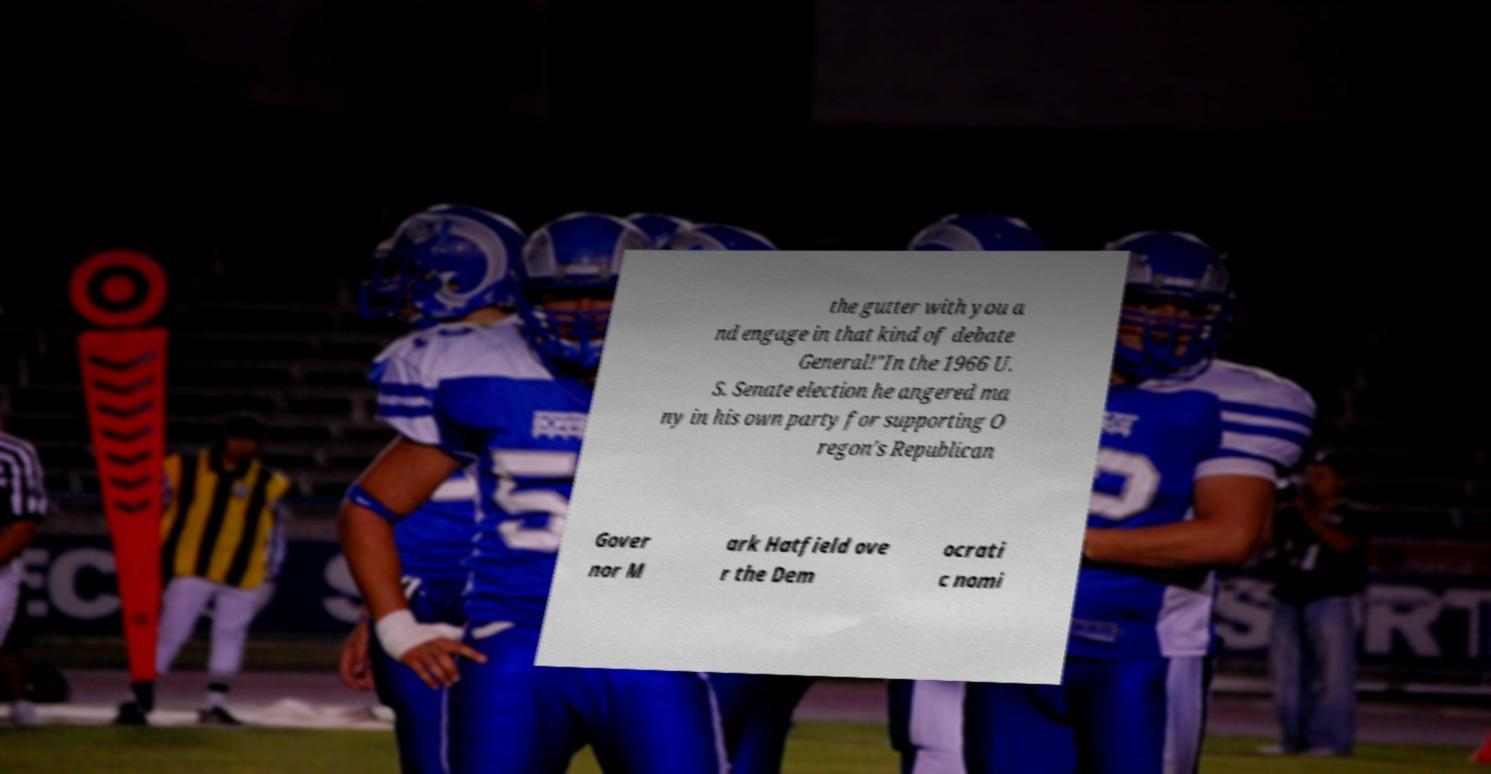Please read and relay the text visible in this image. What does it say? the gutter with you a nd engage in that kind of debate General!"In the 1966 U. S. Senate election he angered ma ny in his own party for supporting O regon's Republican Gover nor M ark Hatfield ove r the Dem ocrati c nomi 